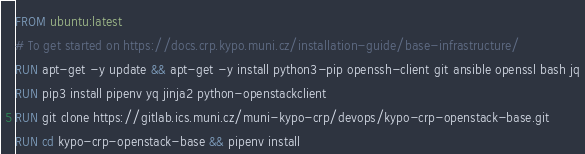Convert code to text. <code><loc_0><loc_0><loc_500><loc_500><_Dockerfile_>FROM ubuntu:latest
# To get started on https://docs.crp.kypo.muni.cz/installation-guide/base-infrastructure/
RUN apt-get -y update && apt-get -y install python3-pip openssh-client git ansible openssl bash jq
RUN pip3 install pipenv yq jinja2 python-openstackclient
RUN git clone https://gitlab.ics.muni.cz/muni-kypo-crp/devops/kypo-crp-openstack-base.git
RUN cd kypo-crp-openstack-base && pipenv install
</code> 